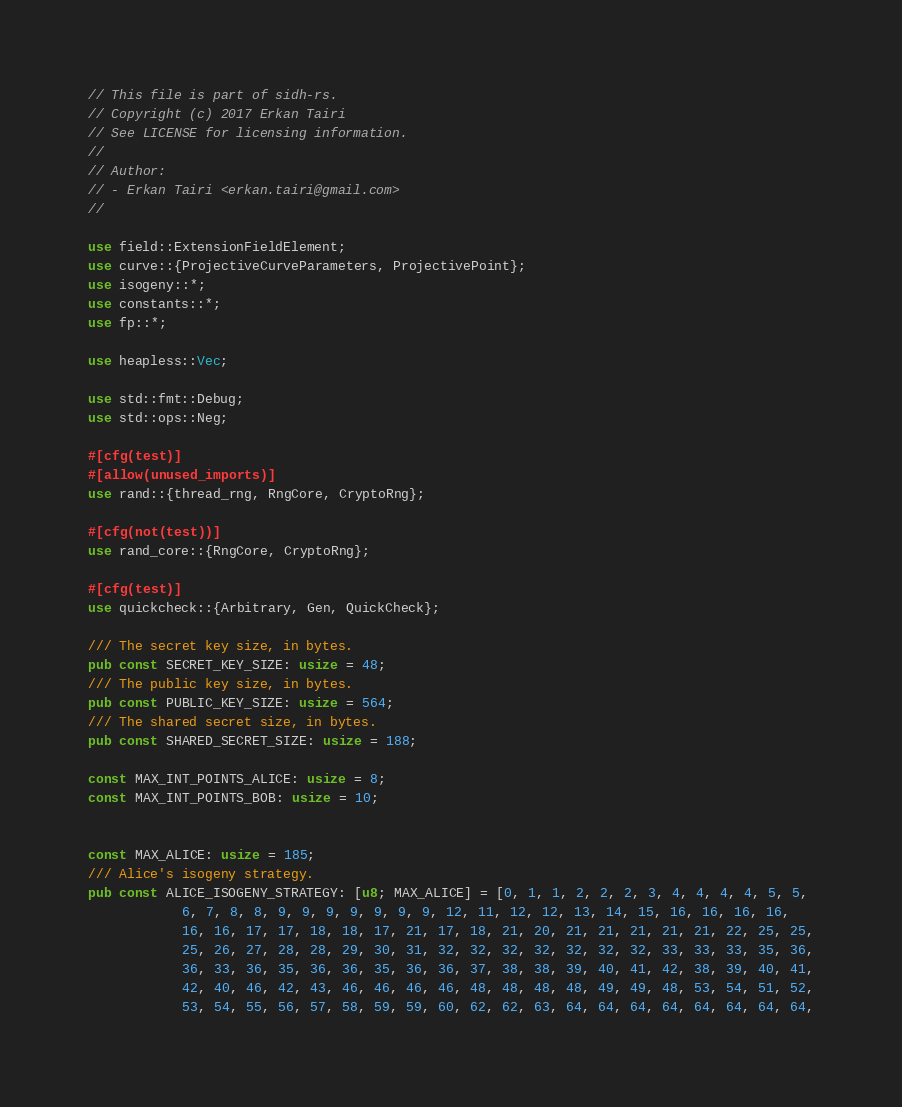<code> <loc_0><loc_0><loc_500><loc_500><_Rust_>// This file is part of sidh-rs.
// Copyright (c) 2017 Erkan Tairi
// See LICENSE for licensing information.
//
// Author:
// - Erkan Tairi <erkan.tairi@gmail.com>
//

use field::ExtensionFieldElement;
use curve::{ProjectiveCurveParameters, ProjectivePoint};
use isogeny::*;
use constants::*;
use fp::*;

use heapless::Vec;

use std::fmt::Debug;
use std::ops::Neg;

#[cfg(test)]
#[allow(unused_imports)]
use rand::{thread_rng, RngCore, CryptoRng};

#[cfg(not(test))]
use rand_core::{RngCore, CryptoRng};

#[cfg(test)]
use quickcheck::{Arbitrary, Gen, QuickCheck};

/// The secret key size, in bytes.
pub const SECRET_KEY_SIZE: usize = 48;
/// The public key size, in bytes.
pub const PUBLIC_KEY_SIZE: usize = 564;
/// The shared secret size, in bytes.
pub const SHARED_SECRET_SIZE: usize = 188;

const MAX_INT_POINTS_ALICE: usize = 8;
const MAX_INT_POINTS_BOB: usize = 10;


const MAX_ALICE: usize = 185;
/// Alice's isogeny strategy.
pub const ALICE_ISOGENY_STRATEGY: [u8; MAX_ALICE] = [0, 1, 1, 2, 2, 2, 3, 4, 4, 4, 4, 5, 5,
	        6, 7, 8, 8, 9, 9, 9, 9, 9, 9, 9, 12, 11, 12, 12, 13, 14, 15, 16, 16, 16, 16,
	        16, 16, 17, 17, 18, 18, 17, 21, 17, 18, 21, 20, 21, 21, 21, 21, 21, 22, 25, 25,
	        25, 26, 27, 28, 28, 29, 30, 31, 32, 32, 32, 32, 32, 32, 32, 33, 33, 33, 35, 36,
	        36, 33, 36, 35, 36, 36, 35, 36, 36, 37, 38, 38, 39, 40, 41, 42, 38, 39, 40, 41,
	        42, 40, 46, 42, 43, 46, 46, 46, 46, 48, 48, 48, 48, 49, 49, 48, 53, 54, 51, 52,
	        53, 54, 55, 56, 57, 58, 59, 59, 60, 62, 62, 63, 64, 64, 64, 64, 64, 64, 64, 64,</code> 